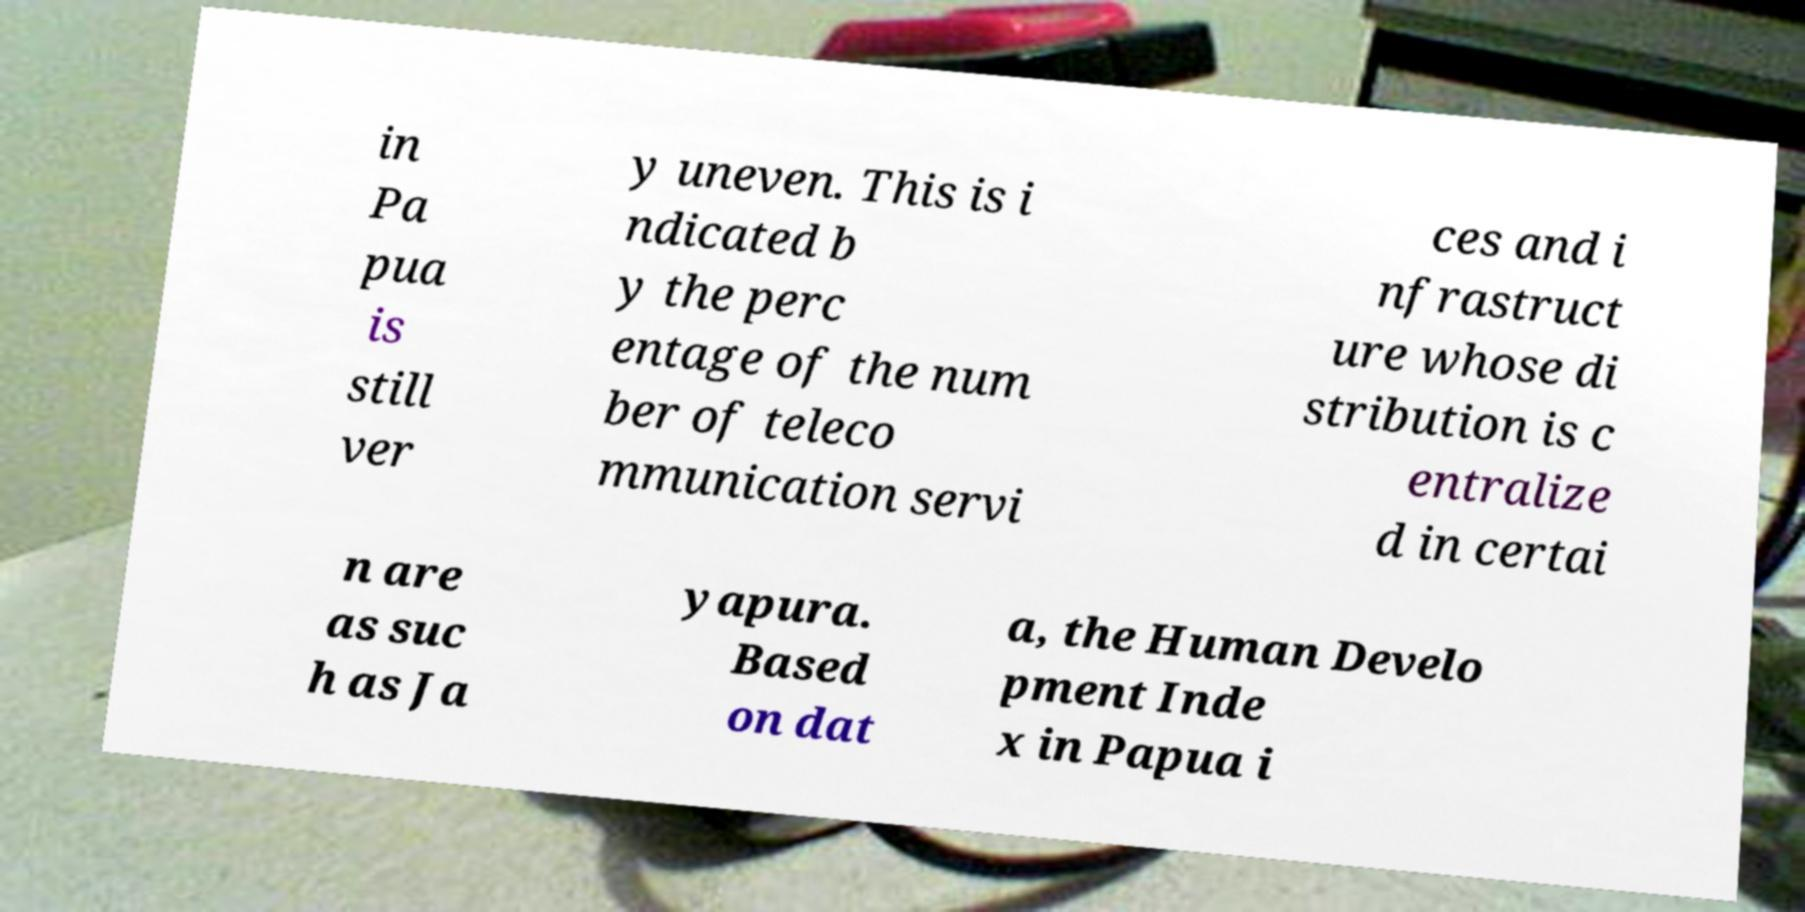Can you read and provide the text displayed in the image?This photo seems to have some interesting text. Can you extract and type it out for me? in Pa pua is still ver y uneven. This is i ndicated b y the perc entage of the num ber of teleco mmunication servi ces and i nfrastruct ure whose di stribution is c entralize d in certai n are as suc h as Ja yapura. Based on dat a, the Human Develo pment Inde x in Papua i 